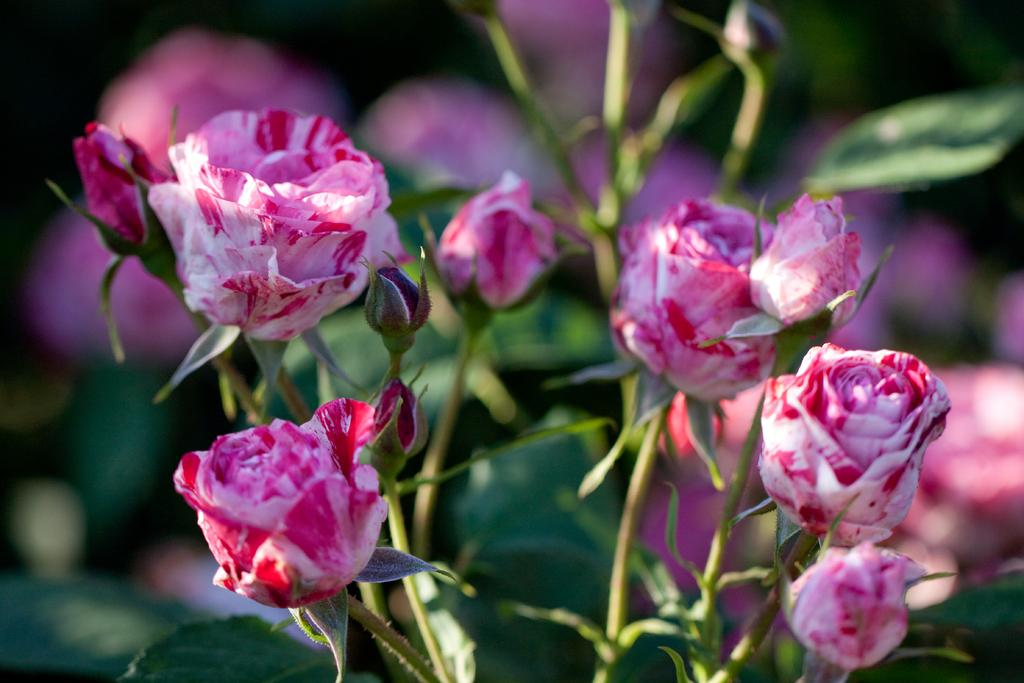What type of flowers are in the image? There are rose flowers in the image. Are there any unopened flowers in the image? Yes, there are rose buds in the image. Where are the flowers and buds located? The rose flowers and buds are on a plant. How would you describe the background of the image? The background of the image is blurred. What type of rail can be seen in the image? There is no rail present in the image; it features rose flowers and buds on a plant. How does the silver color enhance the appearance of the flowers in the image? There is no silver color present in the image; the flowers are primarily red and green. 